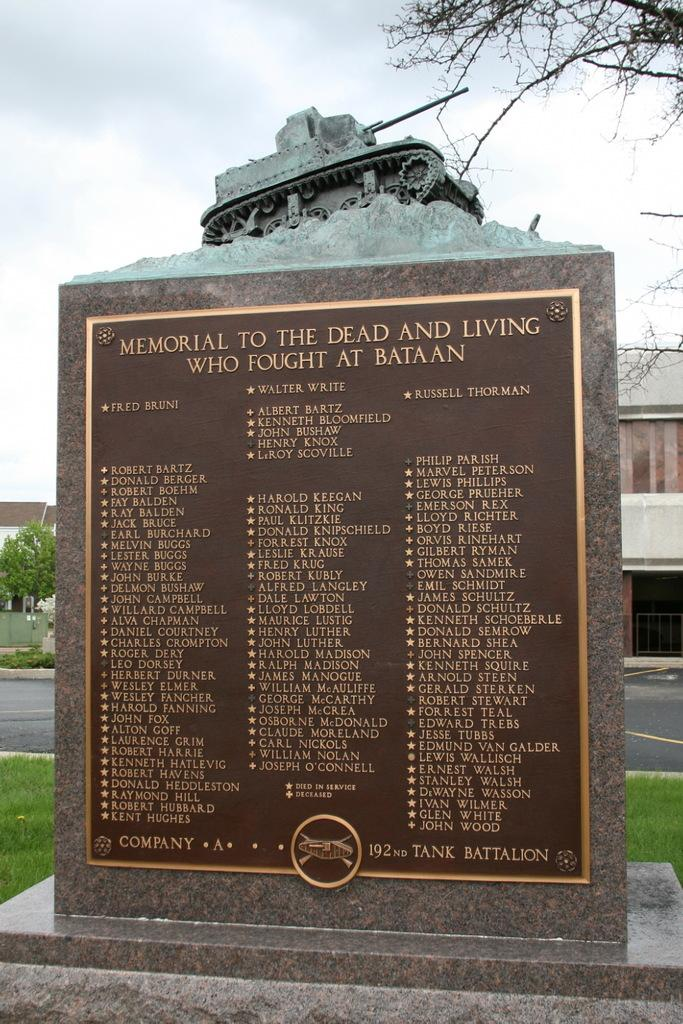What is the main subject of the image? The main subject of the image is a grave with text. What is located on the grave? There is a sculpture on the grave. What can be seen in the background of the image? Trees, a building, grass, a road, and the sky are visible in the background of the image. What type of quartz can be seen on the grave in the image? There is no quartz present on the grave in the image. How many brothers are depicted in the image? There are no people, including brothers, present in the image. 